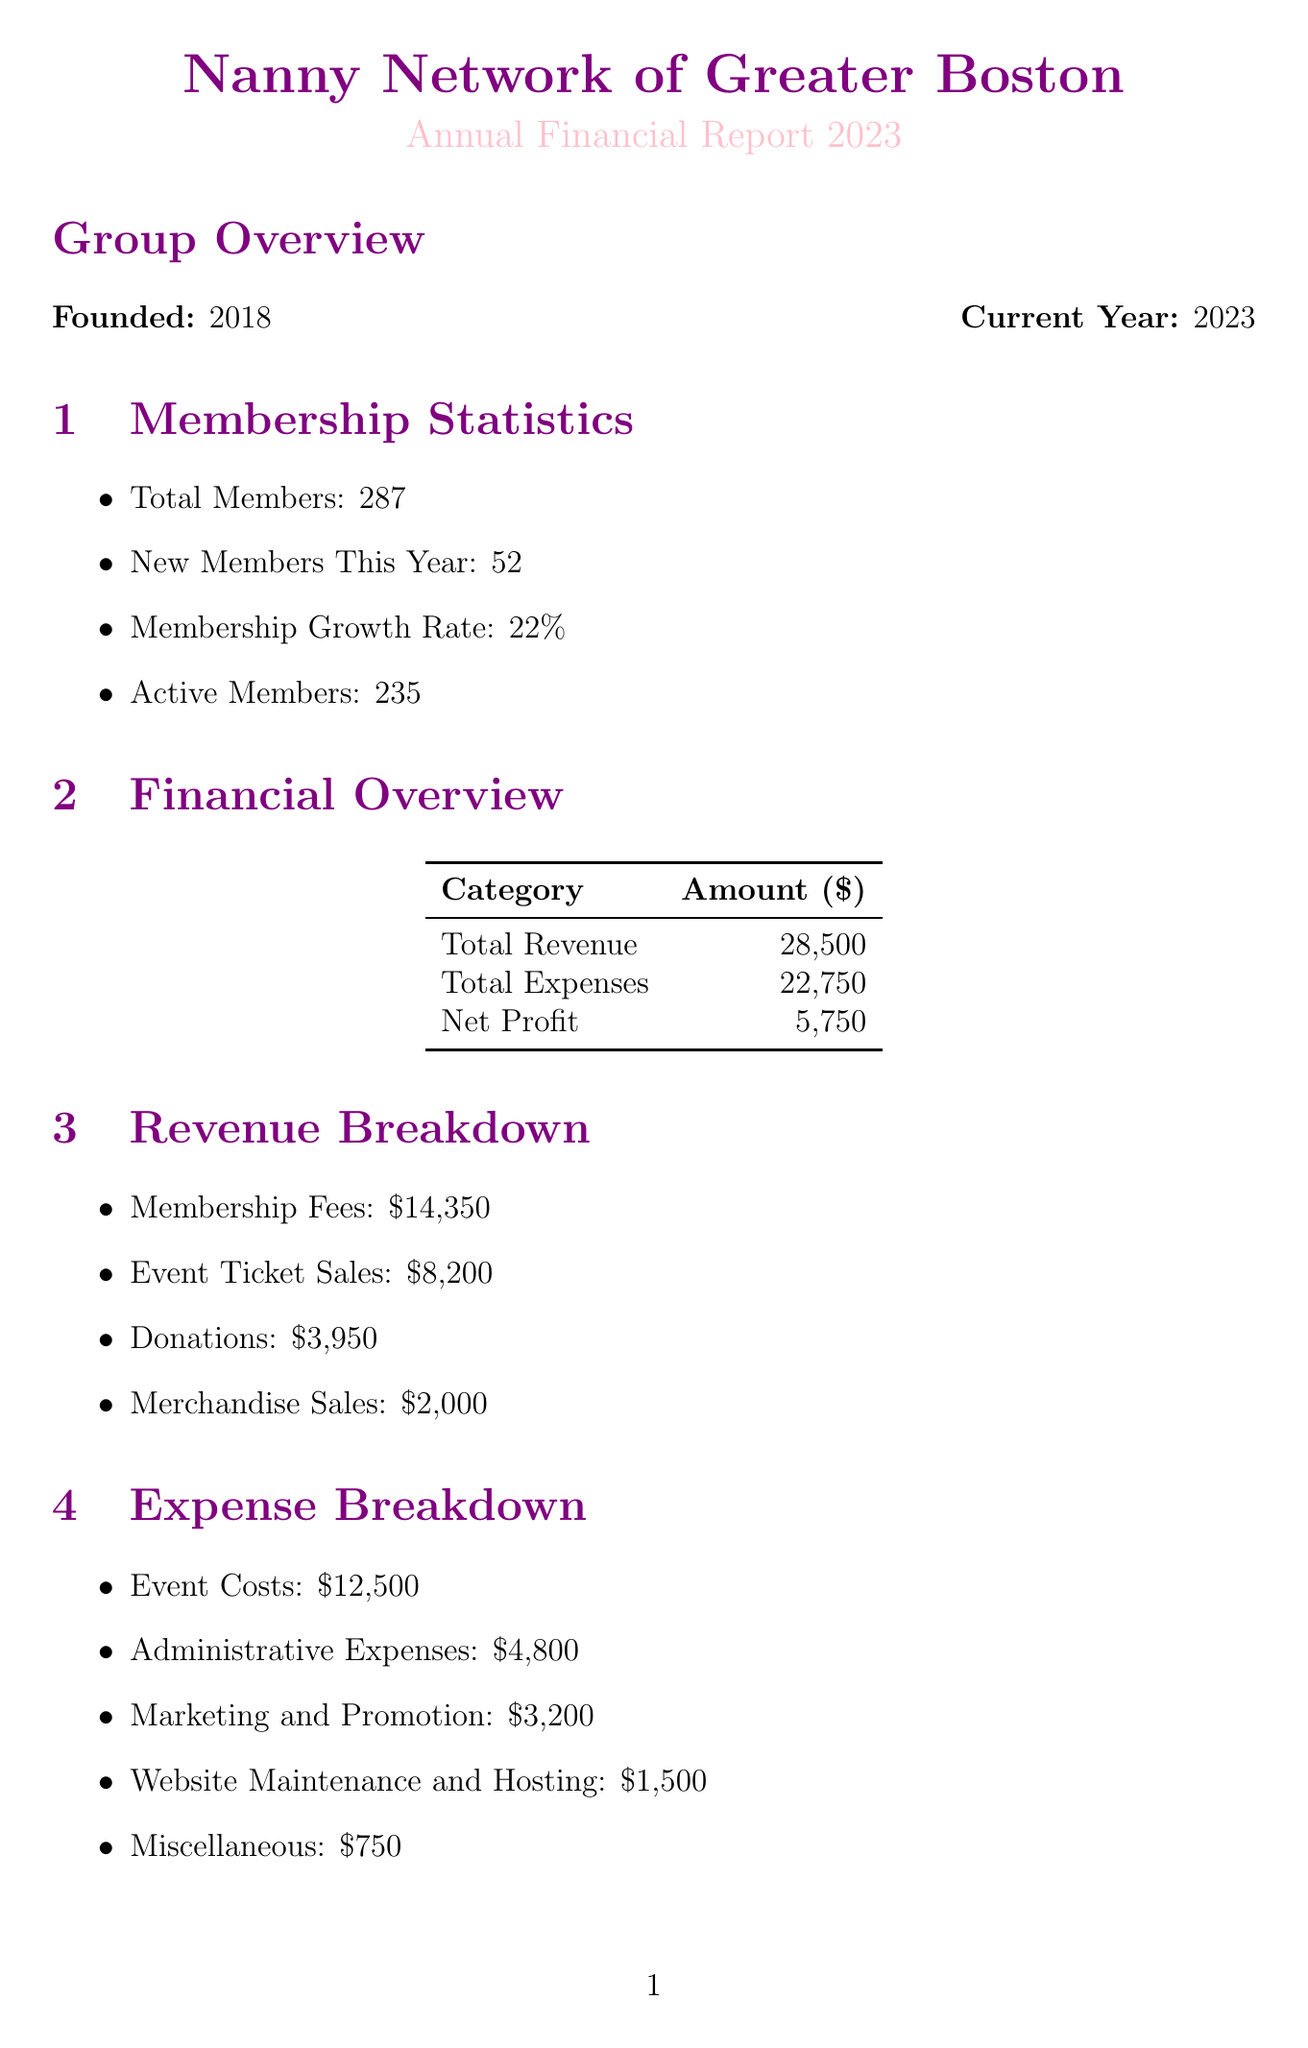what is the total number of members? The total number of members is provided in the membership statistics section of the document.
Answer: 287 what is the membership growth rate? The membership growth rate is specified in the membership statistics section.
Answer: 22% how much were the total expenses? The total expenses can be found in the financial overview section, combining various expenses.
Answer: 22750 what event had the highest revenue? The events section lists the revenue for each event, with the highest recorded revenue being the annual nanny conference.
Answer: Annual Nanny Conference how much did the online auction raise in total? The online auction amount raised is listed under the fundraising efforts section.
Answer: 2750 what percentage increase in membership is targeted for next year? The goals for next year section mentions the targeted percentage increase in membership.
Answer: 30% how many successful placements resulted from the job board? The key achievements section states the number of successful placements achieved through the job board.
Answer: 35 who is the treasurer of the Nanny Network? The board members section includes the name and position of each board member, identifying the treasurer.
Answer: Michael Chen what was the cost of the Holiday Networking Mixer? The cost for the Holiday Networking Mixer is detailed under the major events section of the document.
Answer: 1500 